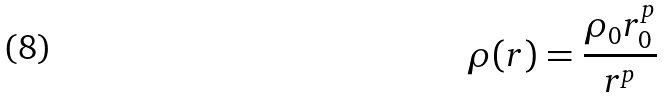Convert formula to latex. <formula><loc_0><loc_0><loc_500><loc_500>\rho ( r ) = \frac { \rho _ { 0 } r _ { 0 } ^ { p } } { r ^ { p } }</formula> 